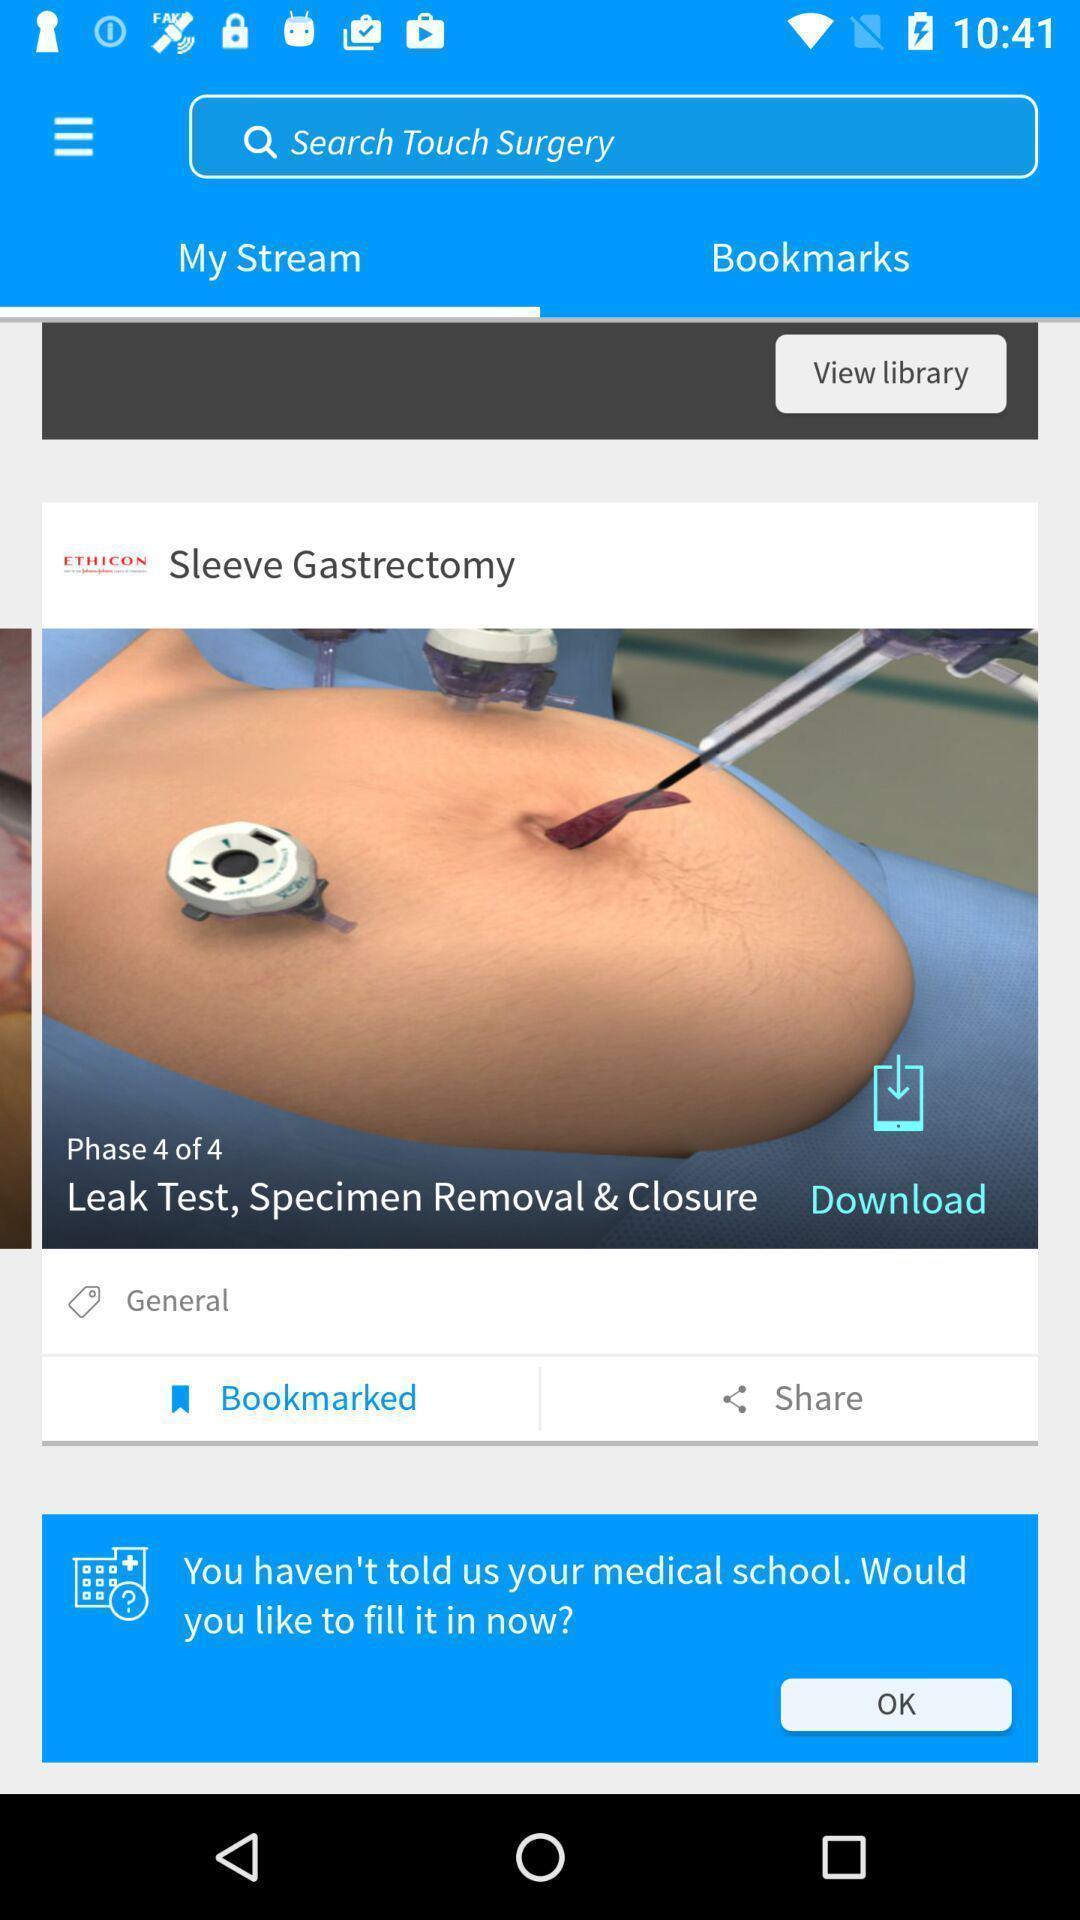Describe this image in words. Screen displaying my stream page. 